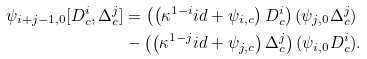<formula> <loc_0><loc_0><loc_500><loc_500>\psi _ { i + j - 1 , 0 } [ D ^ { i } _ { c } , \Delta ^ { j } _ { c } ] & = \left ( \left ( \kappa ^ { 1 - i } i d + \psi _ { i , c } \right ) D ^ { i } _ { c } \right ) ( \psi _ { j , 0 } \Delta ^ { j } _ { c } ) \\ & - \left ( \left ( \kappa ^ { 1 - j } i d + \psi _ { j , c } \right ) \Delta ^ { j } _ { c } \right ) ( \psi _ { i , 0 } D ^ { i } _ { c } ) .</formula> 